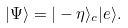<formula> <loc_0><loc_0><loc_500><loc_500>| \Psi \rangle = | - \eta \rangle _ { c } | e \rangle .</formula> 